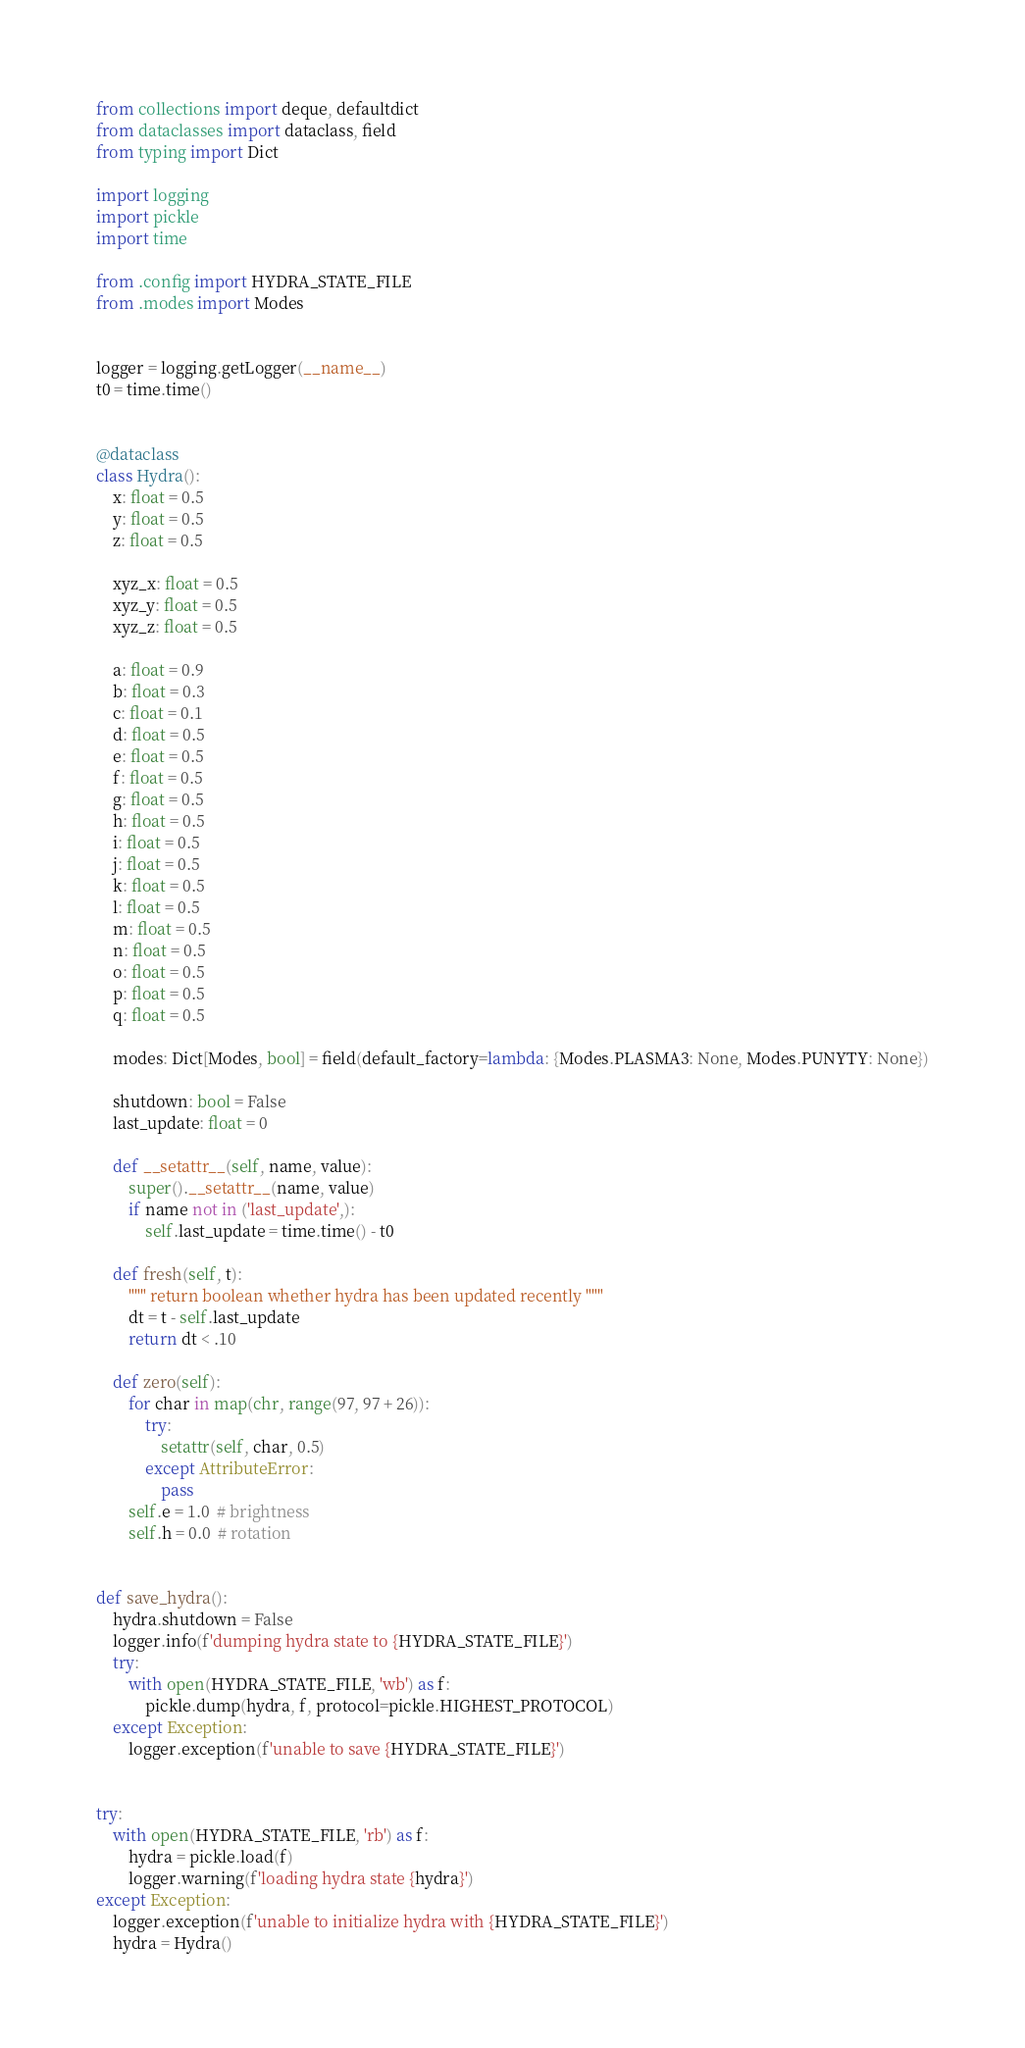Convert code to text. <code><loc_0><loc_0><loc_500><loc_500><_Python_>from collections import deque, defaultdict
from dataclasses import dataclass, field
from typing import Dict

import logging
import pickle
import time

from .config import HYDRA_STATE_FILE
from .modes import Modes


logger = logging.getLogger(__name__)
t0 = time.time()


@dataclass
class Hydra():
    x: float = 0.5
    y: float = 0.5
    z: float = 0.5

    xyz_x: float = 0.5
    xyz_y: float = 0.5
    xyz_z: float = 0.5

    a: float = 0.9
    b: float = 0.3
    c: float = 0.1
    d: float = 0.5
    e: float = 0.5
    f: float = 0.5
    g: float = 0.5
    h: float = 0.5
    i: float = 0.5
    j: float = 0.5
    k: float = 0.5
    l: float = 0.5
    m: float = 0.5
    n: float = 0.5
    o: float = 0.5
    p: float = 0.5
    q: float = 0.5

    modes: Dict[Modes, bool] = field(default_factory=lambda: {Modes.PLASMA3: None, Modes.PUNYTY: None})

    shutdown: bool = False
    last_update: float = 0

    def __setattr__(self, name, value):
        super().__setattr__(name, value)
        if name not in ('last_update',):
            self.last_update = time.time() - t0

    def fresh(self, t):
        """ return boolean whether hydra has been updated recently """
        dt = t - self.last_update
        return dt < .10

    def zero(self):
        for char in map(chr, range(97, 97 + 26)):
            try:
                setattr(self, char, 0.5)
            except AttributeError:
                pass
        self.e = 1.0  # brightness
        self.h = 0.0  # rotation


def save_hydra():
    hydra.shutdown = False
    logger.info(f'dumping hydra state to {HYDRA_STATE_FILE}')
    try:
        with open(HYDRA_STATE_FILE, 'wb') as f:
            pickle.dump(hydra, f, protocol=pickle.HIGHEST_PROTOCOL)
    except Exception:
        logger.exception(f'unable to save {HYDRA_STATE_FILE}')


try:
    with open(HYDRA_STATE_FILE, 'rb') as f:
        hydra = pickle.load(f)
        logger.warning(f'loading hydra state {hydra}')
except Exception:
    logger.exception(f'unable to initialize hydra with {HYDRA_STATE_FILE}')
    hydra = Hydra()
</code> 